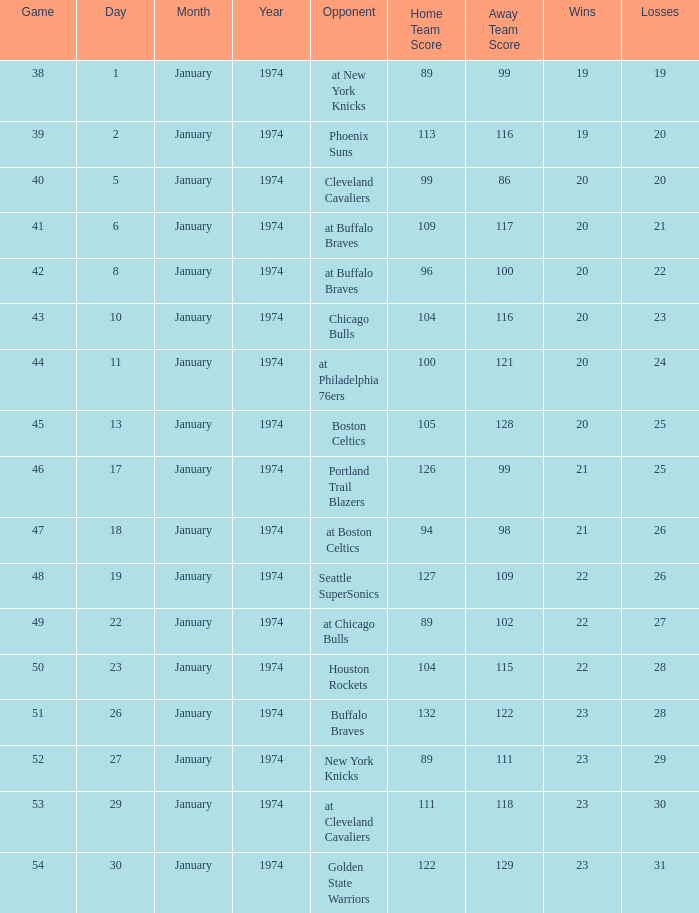What was the record after game 51 on 1/27/1974? 23 - 29. 